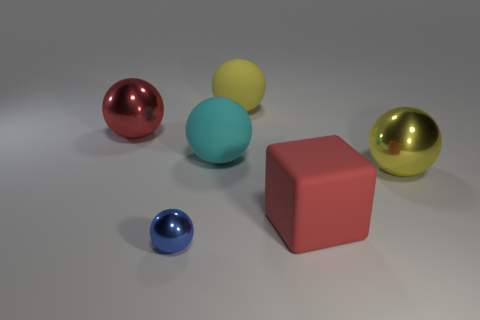Is there a tiny purple sphere? After a careful examination of the image, it appears that there is no tiny purple sphere present among the objects. The objects depicted include a red sphere, a yellow sphere, a cyan sphere, a blue sphere, and a golden sphere, alongside a red cube. None of these objects is a tiny purple sphere. 